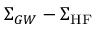<formula> <loc_0><loc_0><loc_500><loc_500>\Sigma _ { G W } - \Sigma _ { H F }</formula> 